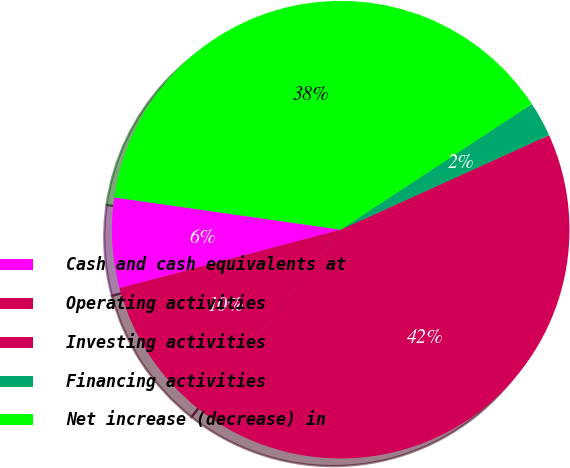Convert chart. <chart><loc_0><loc_0><loc_500><loc_500><pie_chart><fcel>Cash and cash equivalents at<fcel>Operating activities<fcel>Investing activities<fcel>Financing activities<fcel>Net increase (decrease) in<nl><fcel>6.37%<fcel>10.27%<fcel>42.39%<fcel>2.48%<fcel>38.49%<nl></chart> 